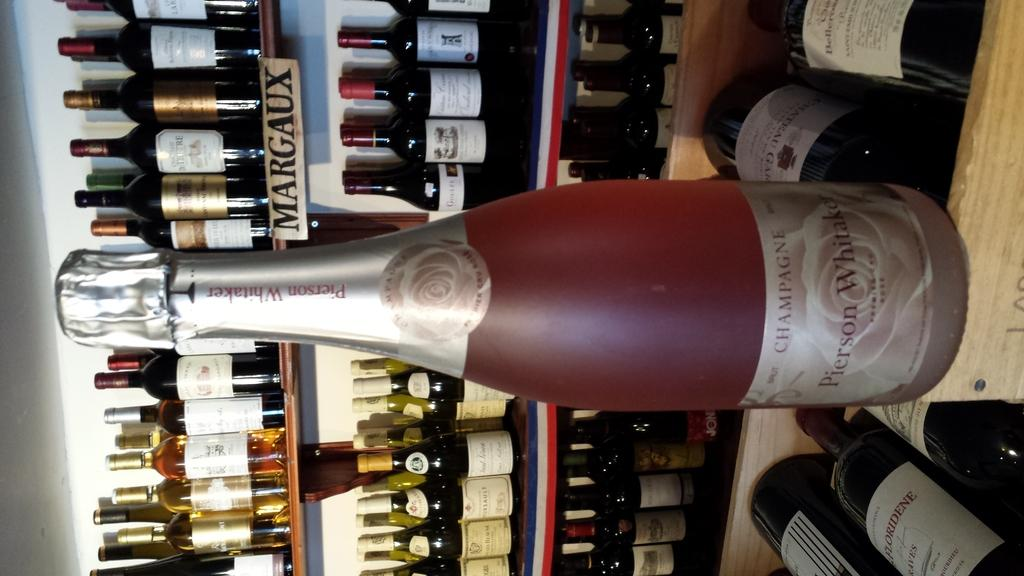<image>
Relay a brief, clear account of the picture shown. a bottle of Pierson Whitaker champagne displayed in front of other winese 